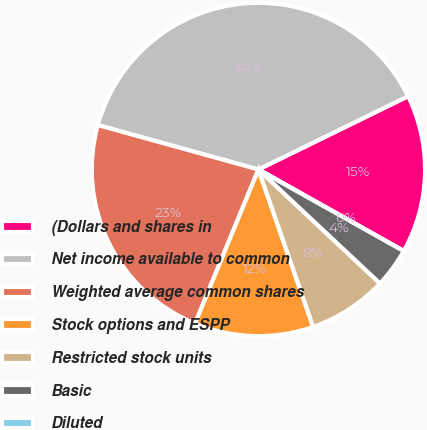Convert chart. <chart><loc_0><loc_0><loc_500><loc_500><pie_chart><fcel>(Dollars and shares in<fcel>Net income available to common<fcel>Weighted average common shares<fcel>Stock options and ESPP<fcel>Restricted stock units<fcel>Basic<fcel>Diluted<nl><fcel>15.38%<fcel>38.46%<fcel>23.08%<fcel>11.54%<fcel>7.69%<fcel>3.85%<fcel>0.0%<nl></chart> 